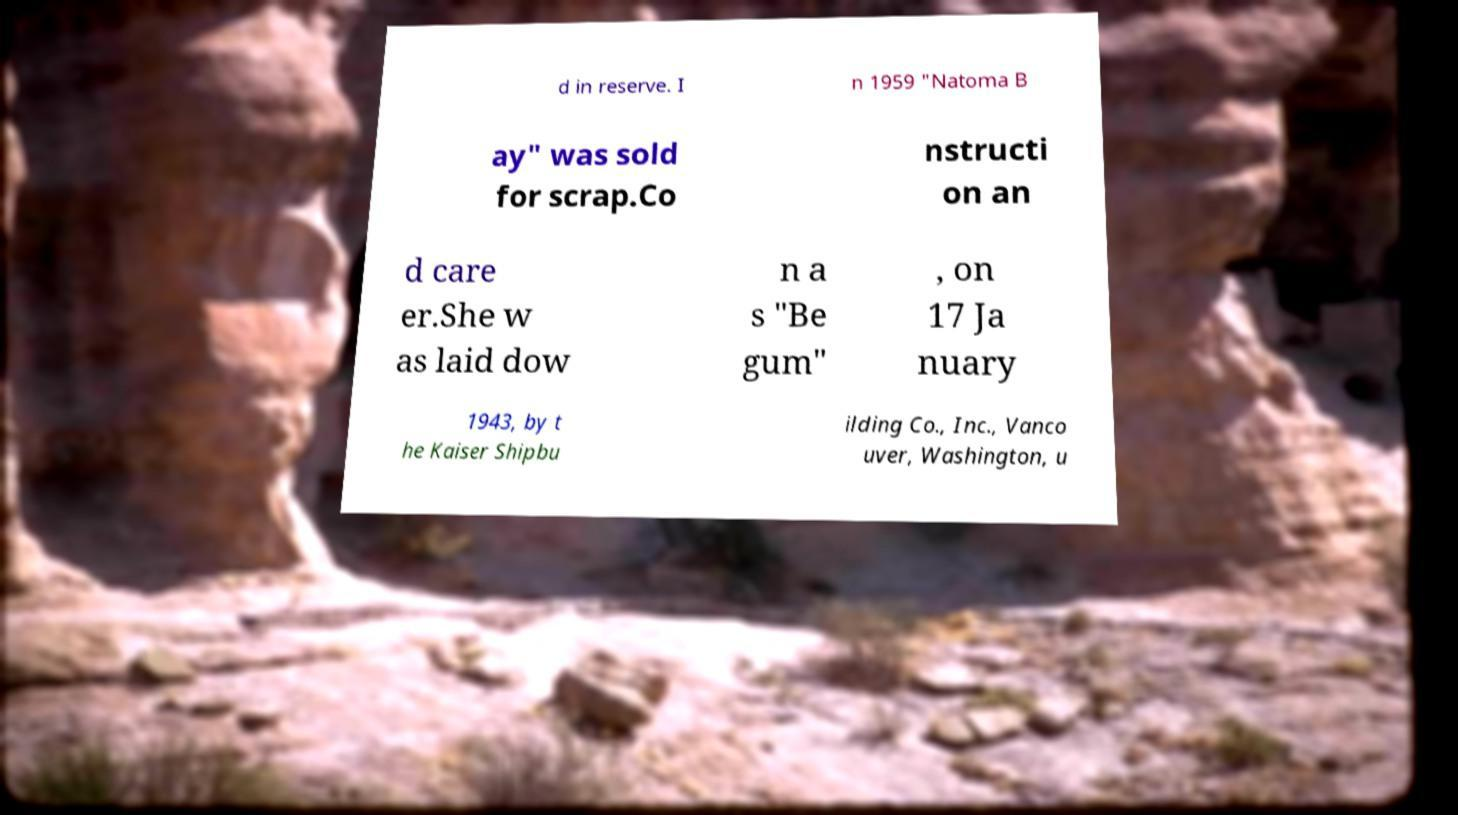Can you accurately transcribe the text from the provided image for me? d in reserve. I n 1959 "Natoma B ay" was sold for scrap.Co nstructi on an d care er.She w as laid dow n a s "Be gum" , on 17 Ja nuary 1943, by t he Kaiser Shipbu ilding Co., Inc., Vanco uver, Washington, u 